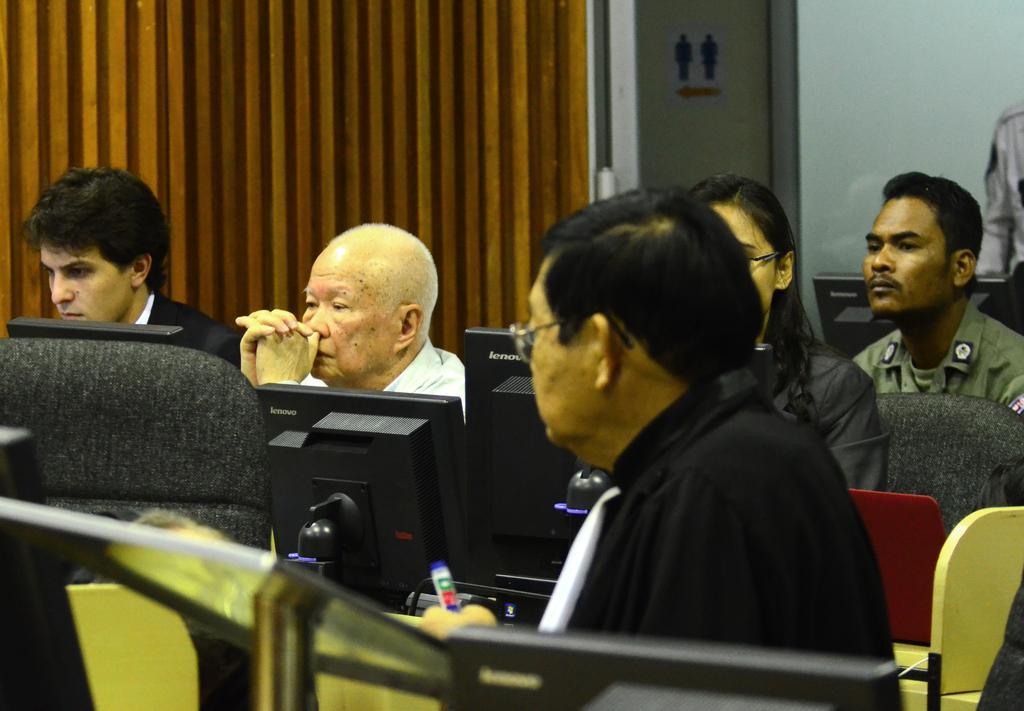Could you give a brief overview of what you see in this image? In this picture there are group of people siting and there are computers on the table. At the back there is a door and there are pictures of two persons on the door and there is a wall. In the foreground there is a man sitting and holding the object. 